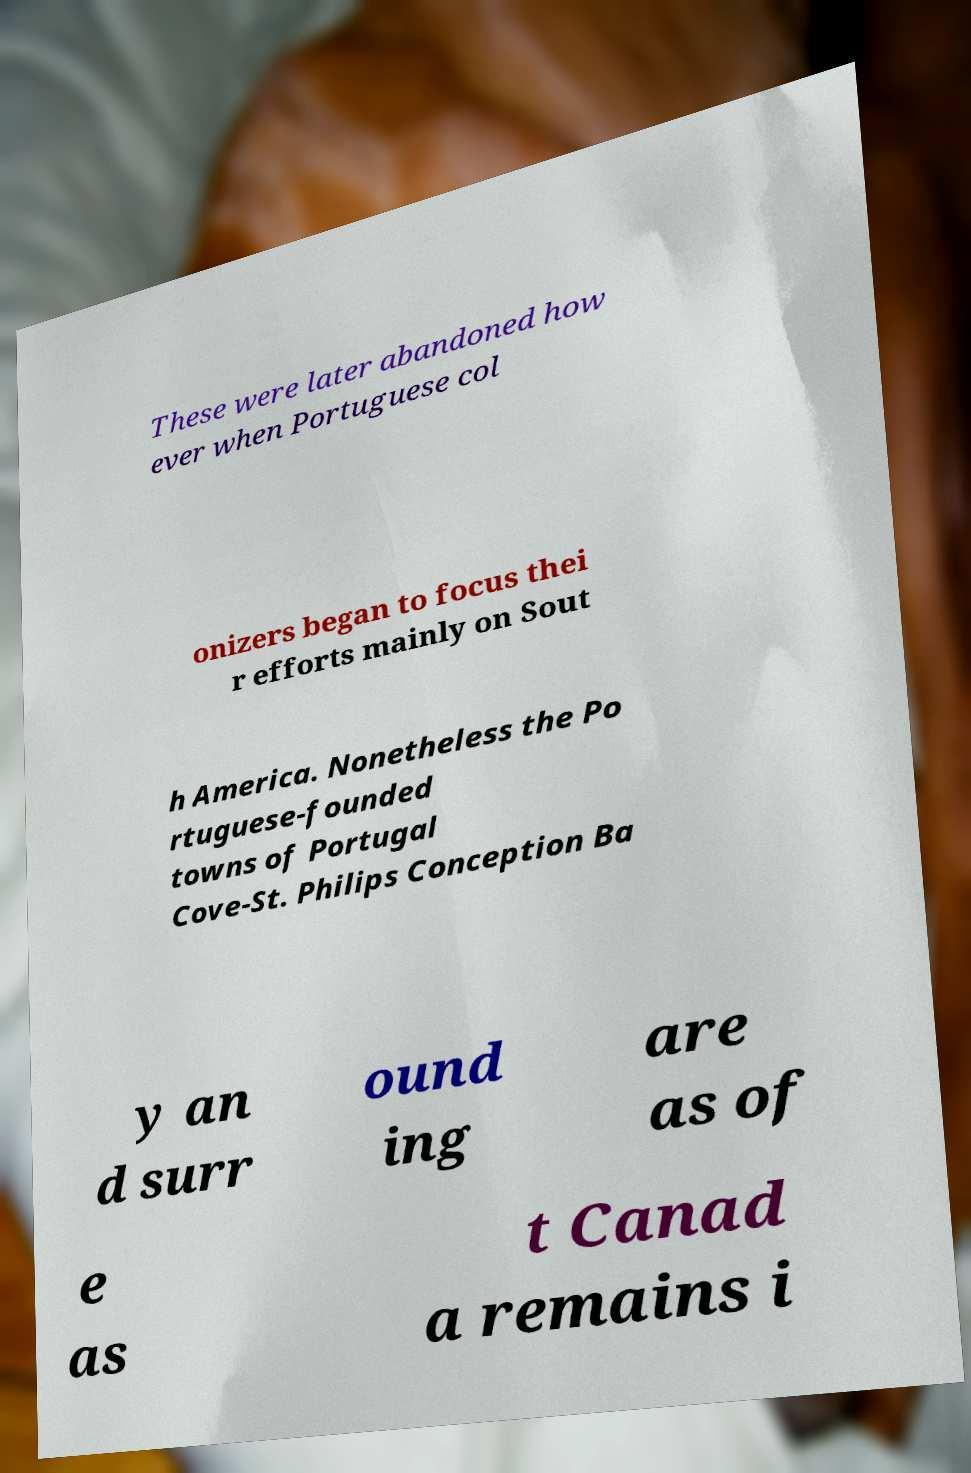I need the written content from this picture converted into text. Can you do that? These were later abandoned how ever when Portuguese col onizers began to focus thei r efforts mainly on Sout h America. Nonetheless the Po rtuguese-founded towns of Portugal Cove-St. Philips Conception Ba y an d surr ound ing are as of e as t Canad a remains i 